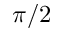Convert formula to latex. <formula><loc_0><loc_0><loc_500><loc_500>\pi / 2</formula> 